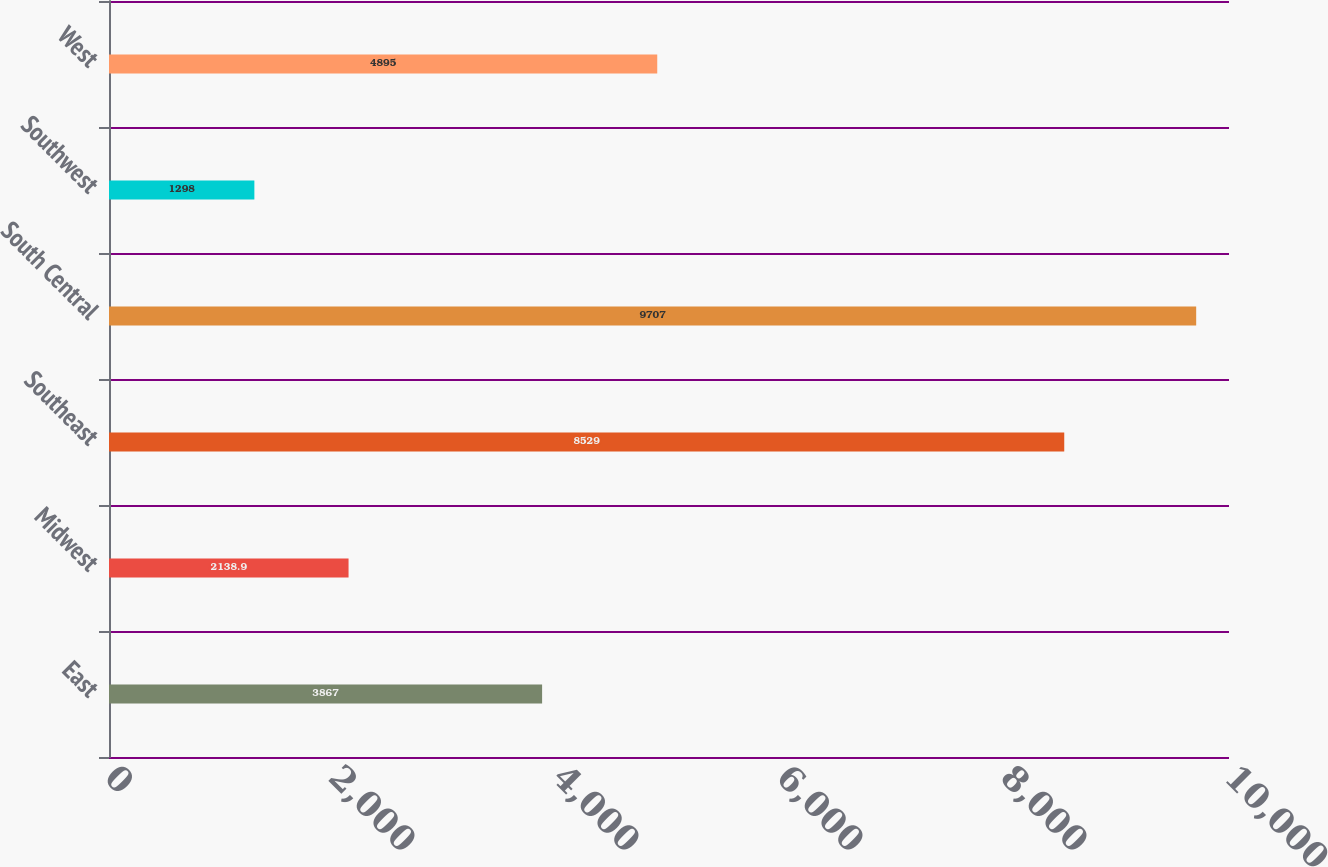Convert chart to OTSL. <chart><loc_0><loc_0><loc_500><loc_500><bar_chart><fcel>East<fcel>Midwest<fcel>Southeast<fcel>South Central<fcel>Southwest<fcel>West<nl><fcel>3867<fcel>2138.9<fcel>8529<fcel>9707<fcel>1298<fcel>4895<nl></chart> 